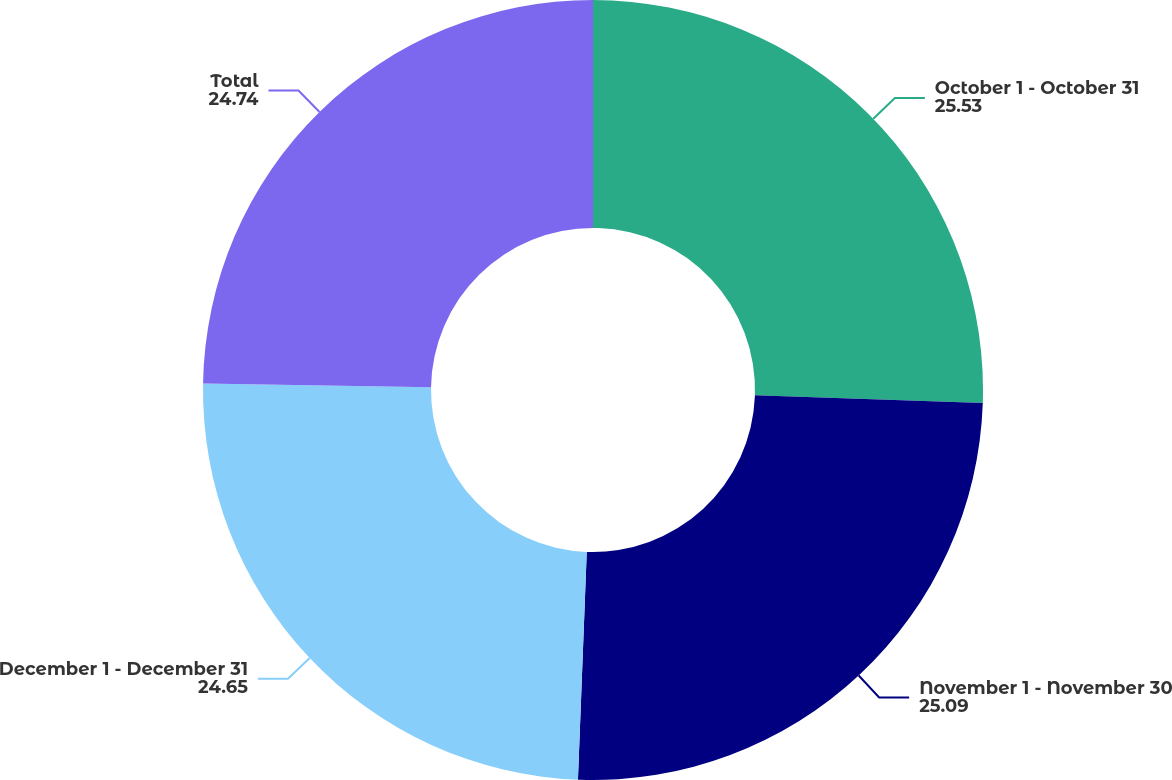Convert chart to OTSL. <chart><loc_0><loc_0><loc_500><loc_500><pie_chart><fcel>October 1 - October 31<fcel>November 1 - November 30<fcel>December 1 - December 31<fcel>Total<nl><fcel>25.53%<fcel>25.09%<fcel>24.65%<fcel>24.74%<nl></chart> 